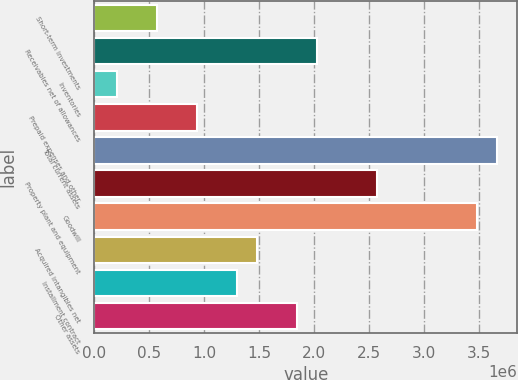Convert chart. <chart><loc_0><loc_0><loc_500><loc_500><bar_chart><fcel>Short-term investments<fcel>Receivables net of allowances<fcel>Inventories<fcel>Prepaid expenses and other<fcel>Total current assets<fcel>Property plant and equipment<fcel>Goodwill<fcel>Acquired intangibles net<fcel>Installment contract<fcel>Other assets<nl><fcel>570122<fcel>2.02679e+06<fcel>205956<fcel>934288<fcel>3.66554e+06<fcel>2.57304e+06<fcel>3.48345e+06<fcel>1.48054e+06<fcel>1.29845e+06<fcel>1.8447e+06<nl></chart> 